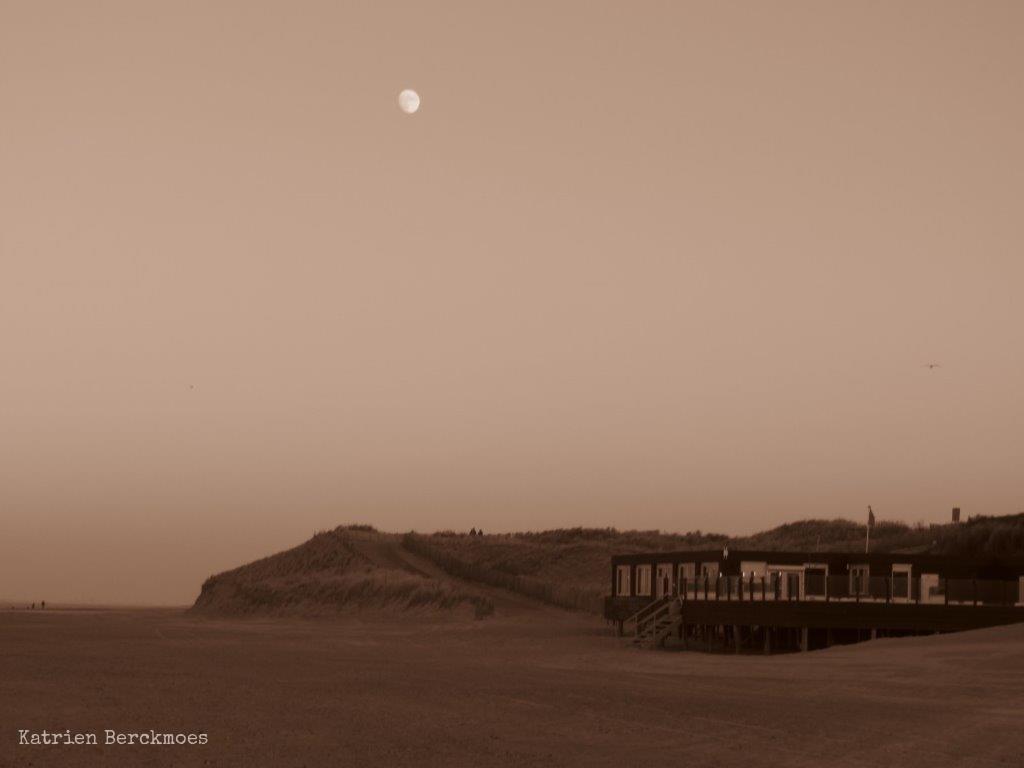In one or two sentences, can you explain what this image depicts? In this image we can see a building, beside the building we can see a hill, at the top of the image in the sky we can see the moon. 